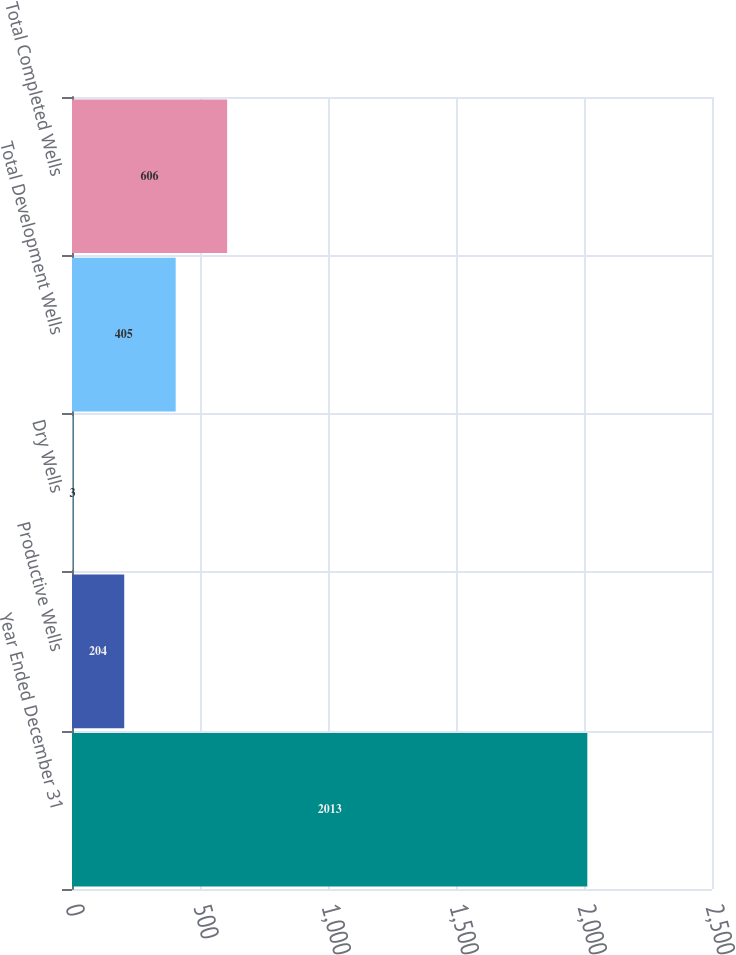Convert chart to OTSL. <chart><loc_0><loc_0><loc_500><loc_500><bar_chart><fcel>Year Ended December 31<fcel>Productive Wells<fcel>Dry Wells<fcel>Total Development Wells<fcel>Total Completed Wells<nl><fcel>2013<fcel>204<fcel>3<fcel>405<fcel>606<nl></chart> 